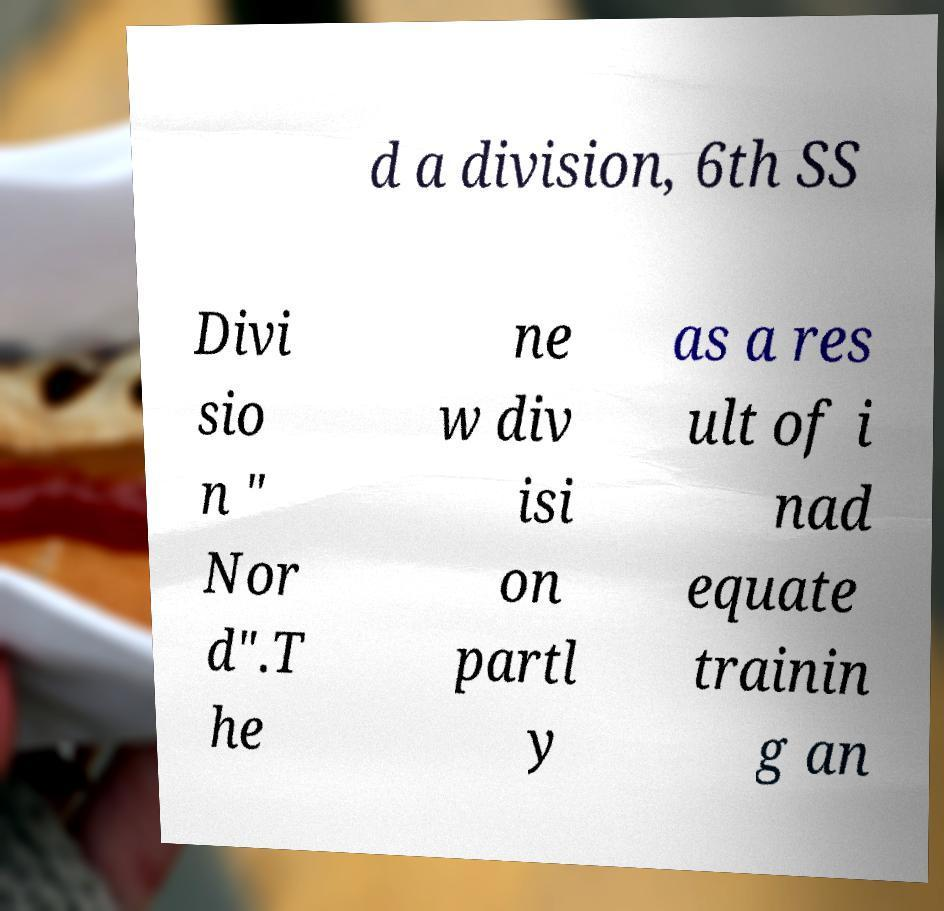Please identify and transcribe the text found in this image. d a division, 6th SS Divi sio n " Nor d".T he ne w div isi on partl y as a res ult of i nad equate trainin g an 